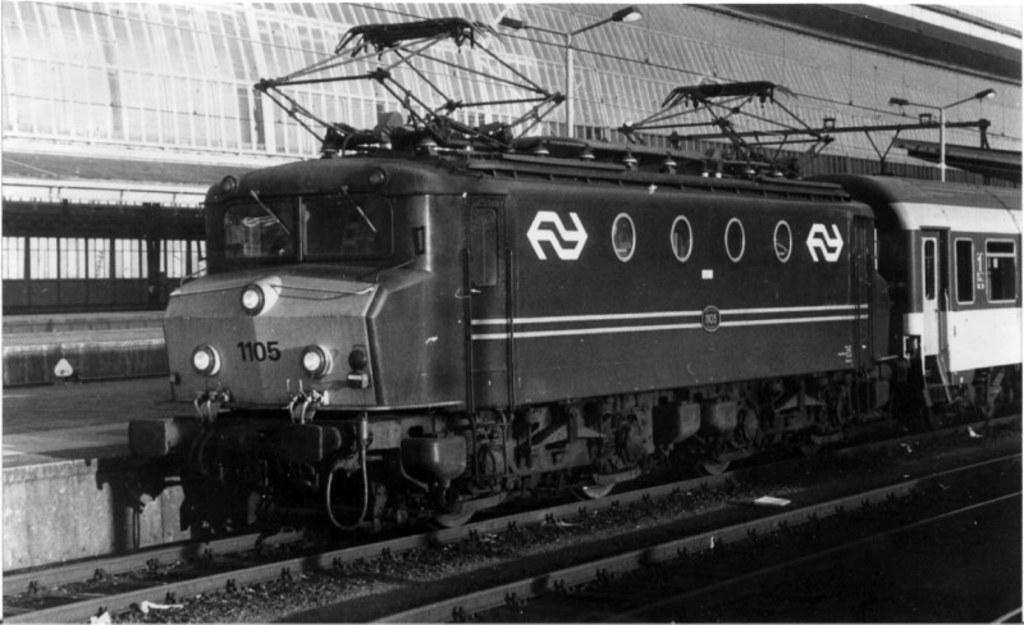In one or two sentences, can you explain what this image depicts? In this image, we can see a train on the track. At the bottom, we can see few tracks. Background we can see platform, shed, poles. Top of the image, we can see lights. 